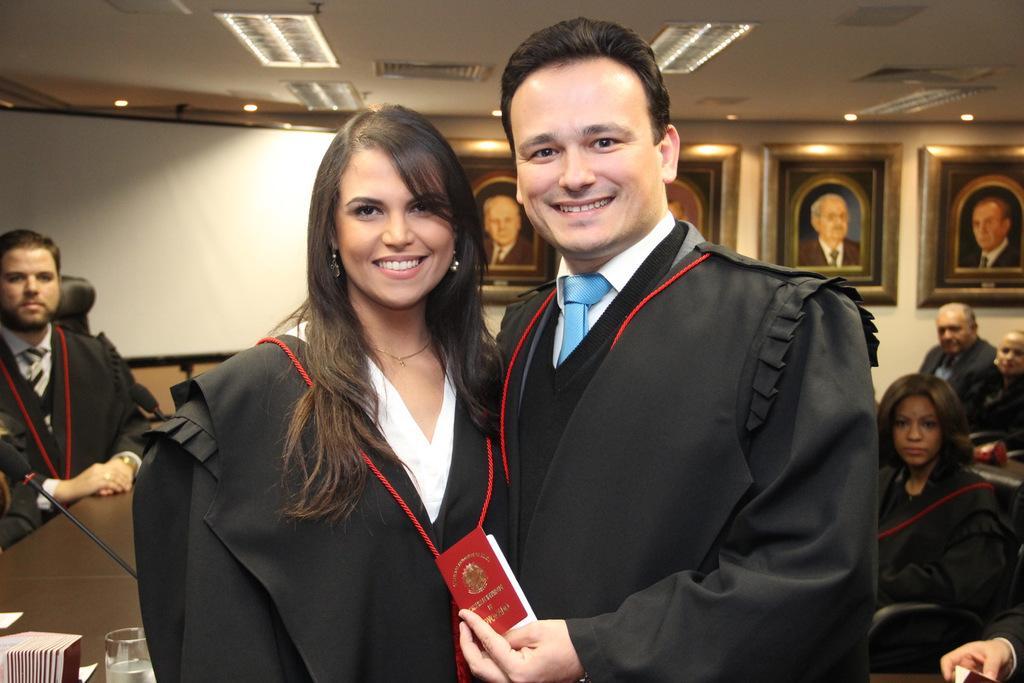How would you summarize this image in a sentence or two? In this image, we can see persons wearing clothes. There are photo frames on the wall. There is a table in the bottom left of the image contains a glass and some cards. There are lights on the ceiling which is at the top of the image. 